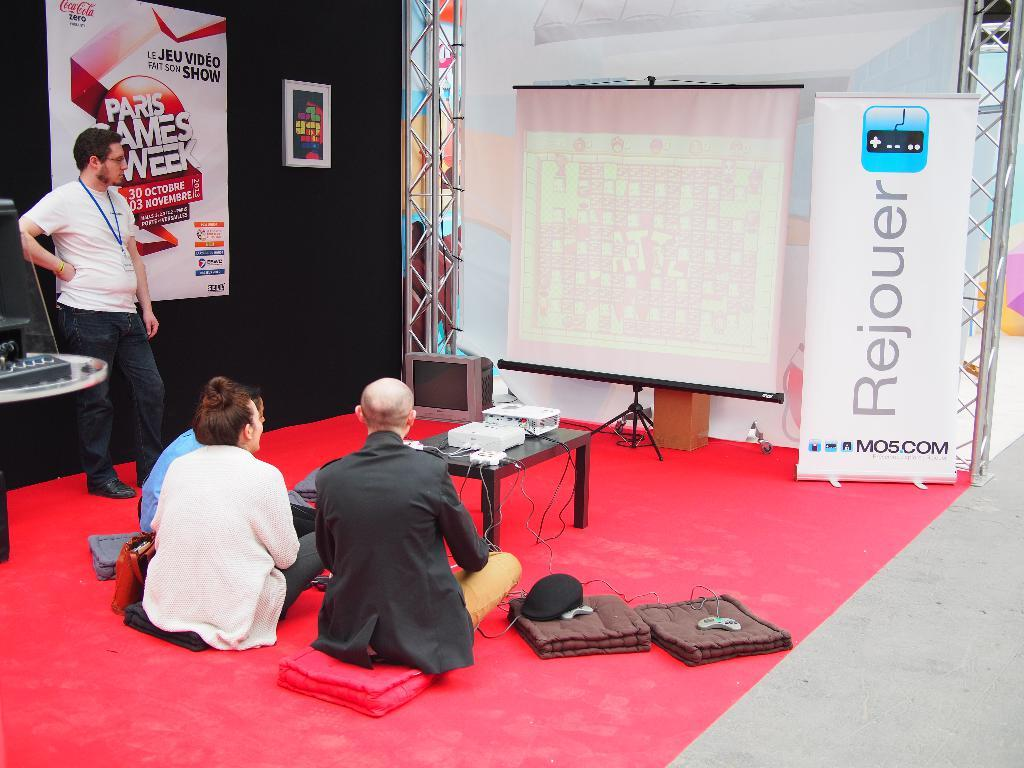What is the man in the image doing? The man is standing in the image. How many people are sitting on the floor in the image? There are three people sitting on the floor in the image. What is on the table in the image? There is a projector on the table in the image. What is in front of the table in the image? There is a screen in front of the table in the image. What type of fog can be seen in the image? There is no fog present in the image. What is being served for dinner in the image? There is no dinner being served in the image; it is focused on the people and the projector setup. 